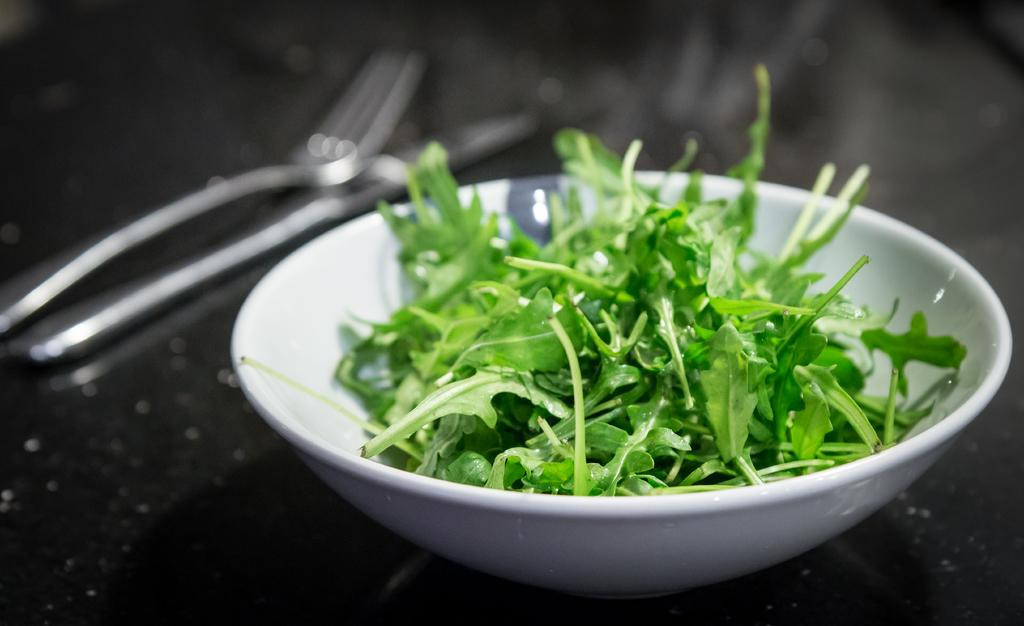What is in the bowl in the image? There are leaves of a plant in a bowl. What utensils are visible in the image? There is a fork and a knife in the image. Where are the leaves, fork, and knife located? They are on a platform. How does the nerve affect the apple in the image? There is no apple or nerve present in the image; it only features leaves of a plant, a fork, and a knife on a platform. 